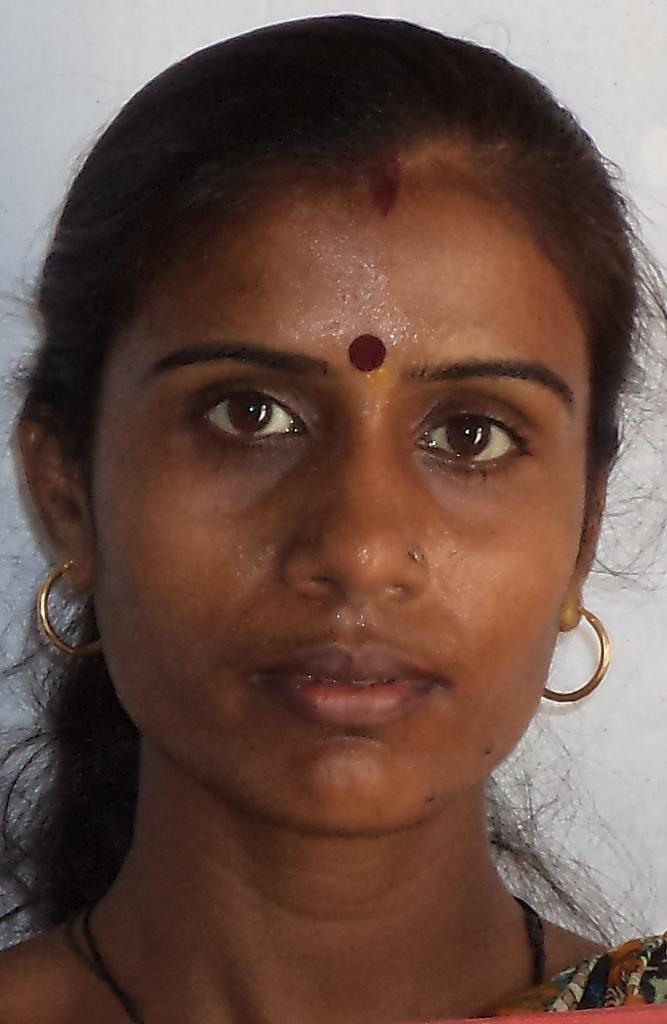Who is present in the image? There is a woman in the image. What type of caption is written on the balloon held by the woman in the image? There is no balloon or caption present in the image; it only features a woman. 